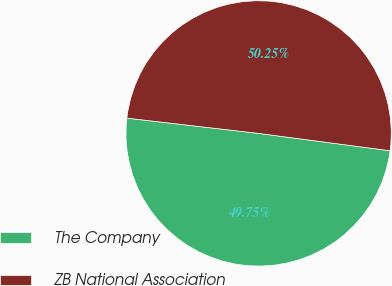Convert chart. <chart><loc_0><loc_0><loc_500><loc_500><pie_chart><fcel>The Company<fcel>ZB National Association<nl><fcel>49.75%<fcel>50.25%<nl></chart> 